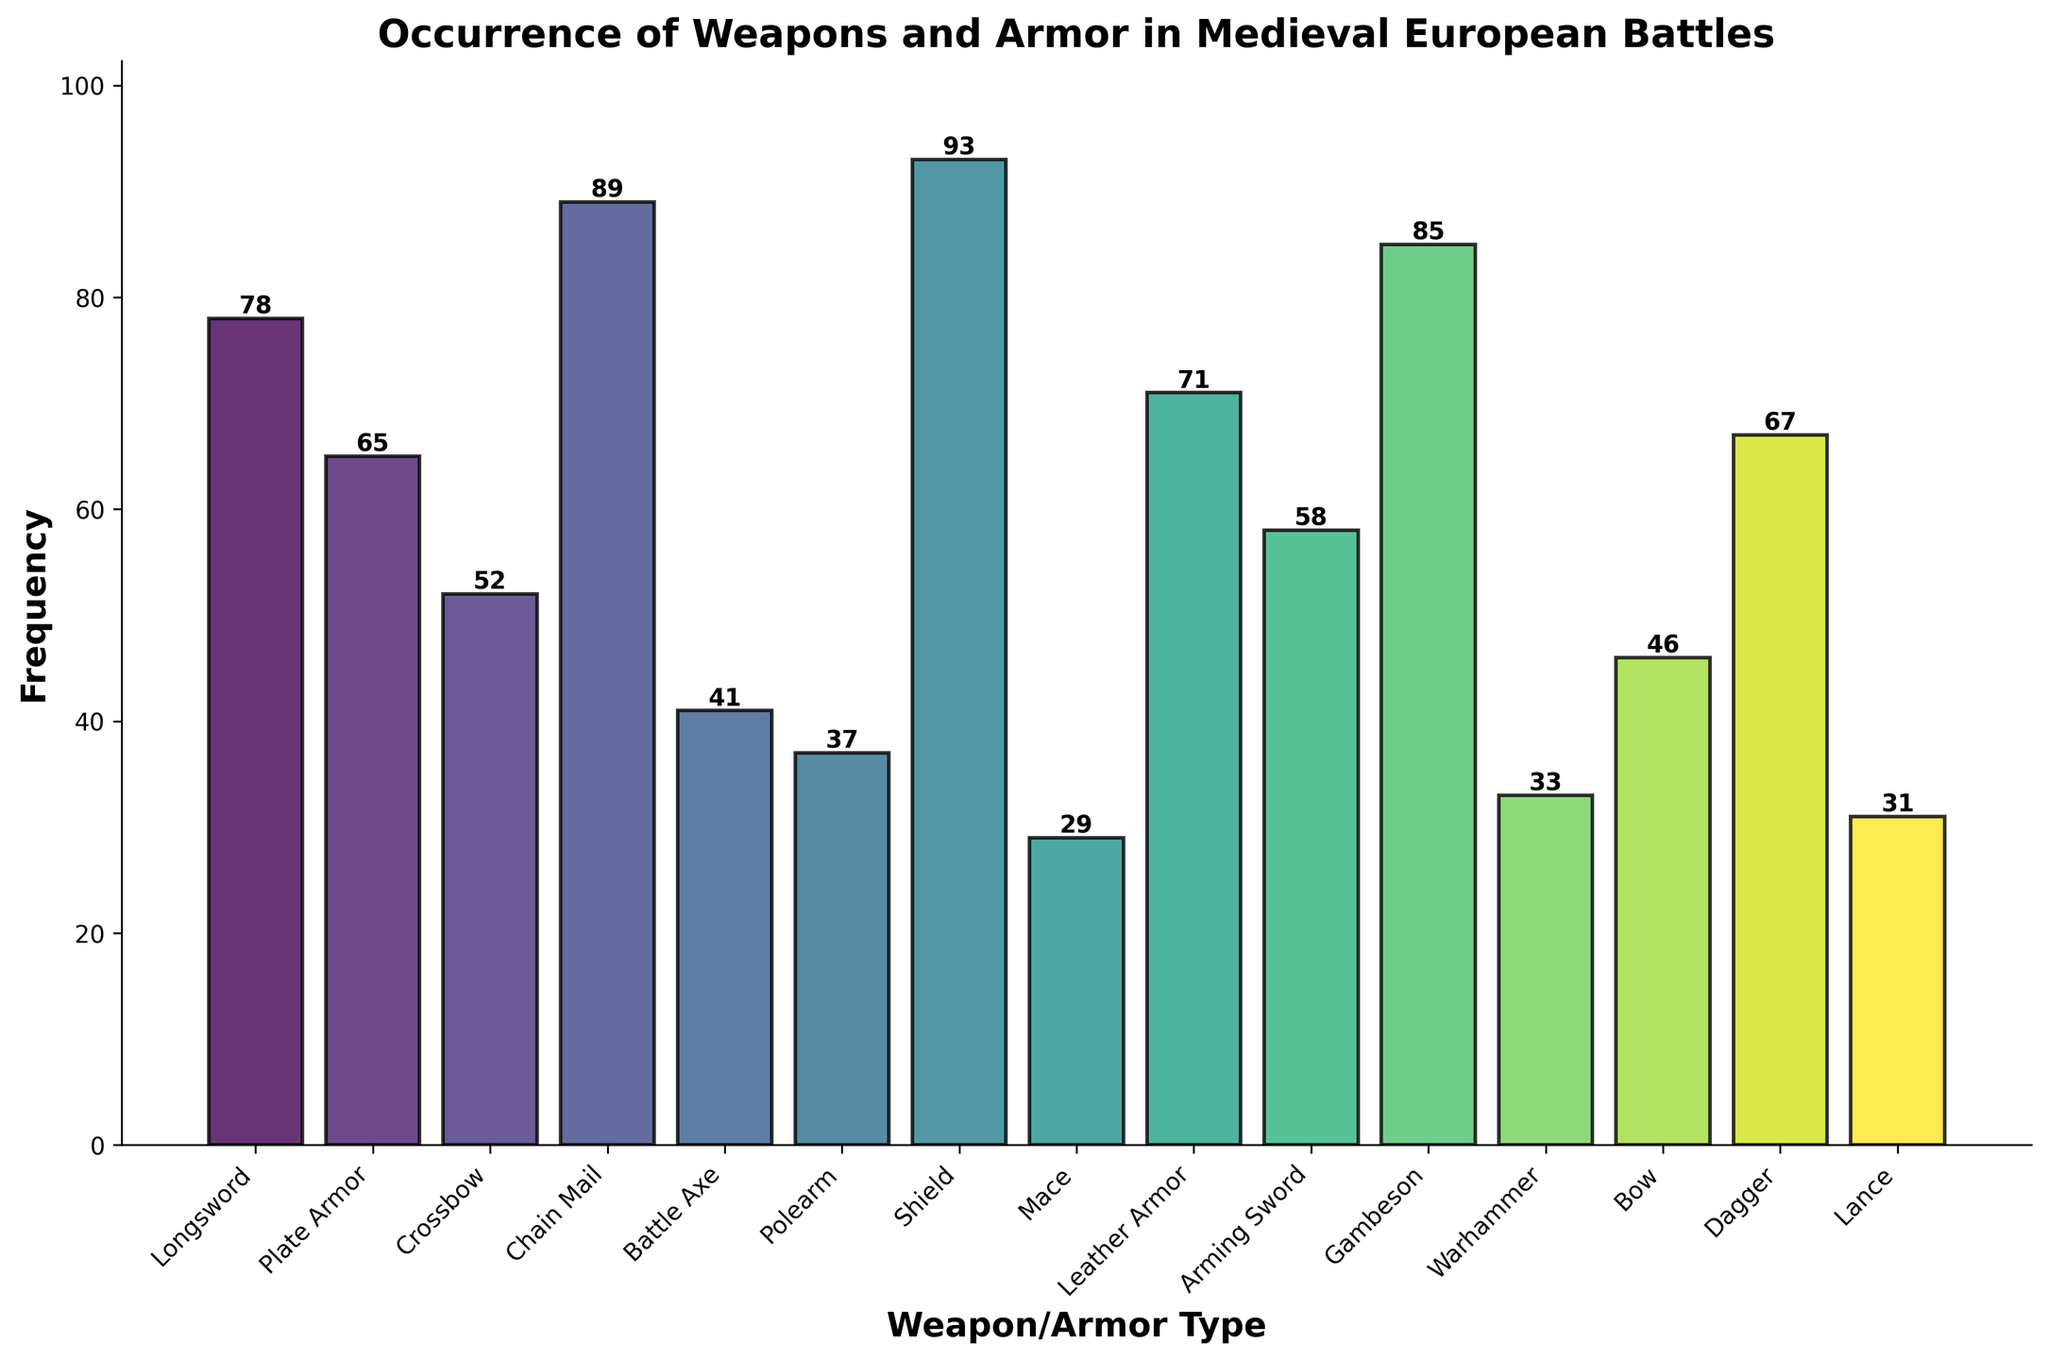What is the most common weapon or armor type in the figure? The height of the bars represents the frequency, and the highest bar corresponds to "Shield" with a frequency of 93.
Answer: Shield How many more occurrences are there of Chain Mail compared to Plate Armor? Chain Mail has a frequency of 89, and Plate Armor has a frequency of 65. The difference is 89 - 65.
Answer: 24 How are the weapon and armor types arranged on the x-axis? The weapon and armor types are arranged from left to right in the order provided: Longsword, Plate Armor, Crossbow, Chain Mail, Battle Axe, Polearm, Shield, Mace, Leather Armor, Arming Sword, Gambeson, Warhammer, Bow, Dagger, Lance.
Answer: In the order given Which weapon or armor has the lowest occurrence? The bar with the lowest height corresponds to "Mace" with a frequency of 29.
Answer: Mace How many types have more than 70 occurrences? The types with more than 70 occurrences are those with bars higher than 70 on the y-axis: Longsword (78), Chain Mail (89), Shield (93), Leather Armor (71), Gambeson (85), and Dagger (67).
Answer: 5 What is the total frequency of Crossbow, Polearm, and Bow? Add the frequencies of Crossbow (52), Polearm (37), and Bow (46). Total is 52 + 37 + 46.
Answer: 135 Which has a greater frequency: Arming Sword or Warhammer? The heights of the bars show that Arming Sword has a frequency of 58, while Warhammer has a frequency of 33.
Answer: Arming Sword What is the sum of occurrences of the top three most common items? The frequencies of the top three items are Shield (93), Chain Mail (89), and Gambeson (85). Sum them: 93 + 89 + 85.
Answer: 267 Does Chain Mail have more occurrences than Longsword? Compare the heights of the bars for Chain Mail (89) and Longsword (78).
Answer: Yes Are there more occurrences of Lance or Warhammer? The bar for Lance shows a frequency of 31, while the bar for Warhammer shows a frequency of 33.
Answer: Warhammer 